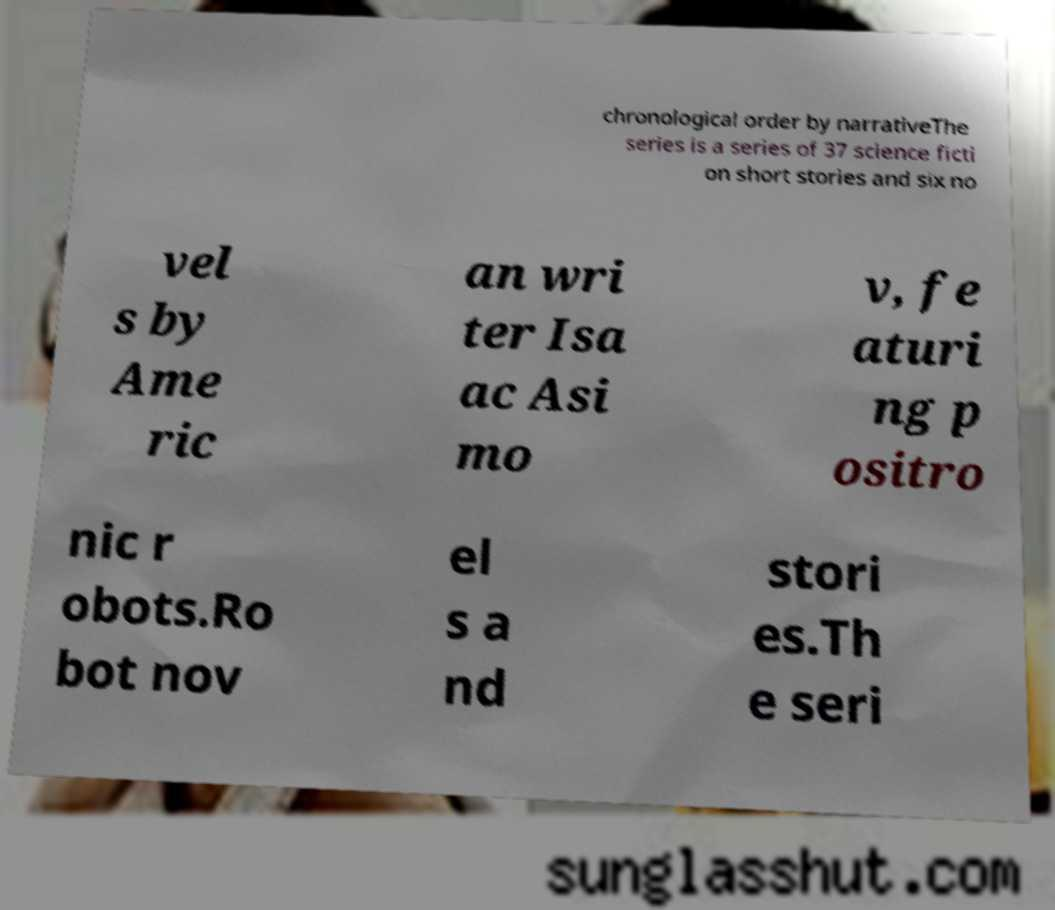I need the written content from this picture converted into text. Can you do that? chronological order by narrativeThe series is a series of 37 science ficti on short stories and six no vel s by Ame ric an wri ter Isa ac Asi mo v, fe aturi ng p ositro nic r obots.Ro bot nov el s a nd stori es.Th e seri 